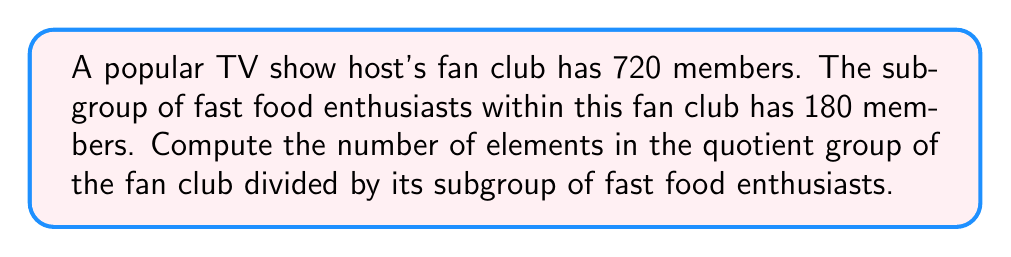Could you help me with this problem? Let's approach this step-by-step:

1) Let $G$ be the group representing the entire fan club, and $H$ be the subgroup of fast food enthusiasts.

2) We're given that:
   $|G| = 720$ (total number of fan club members)
   $|H| = 180$ (number of fast food enthusiasts)

3) The quotient group $G/H$ is the set of all cosets of $H$ in $G$. The number of elements in $G/H$ is equal to the index of $H$ in $G$, denoted as $[G:H]$.

4) The Lagrange's theorem states that for a finite group $G$ and a subgroup $H$ of $G$:

   $$|G| = |H| \cdot [G:H]$$

5) Rearranging this equation, we get:

   $$[G:H] = \frac{|G|}{|H|}$$

6) Substituting the given values:

   $$[G:H] = \frac{720}{180}$$

7) Simplifying:

   $$[G:H] = 4$$

Therefore, the quotient group $G/H$ has 4 elements.
Answer: 4 